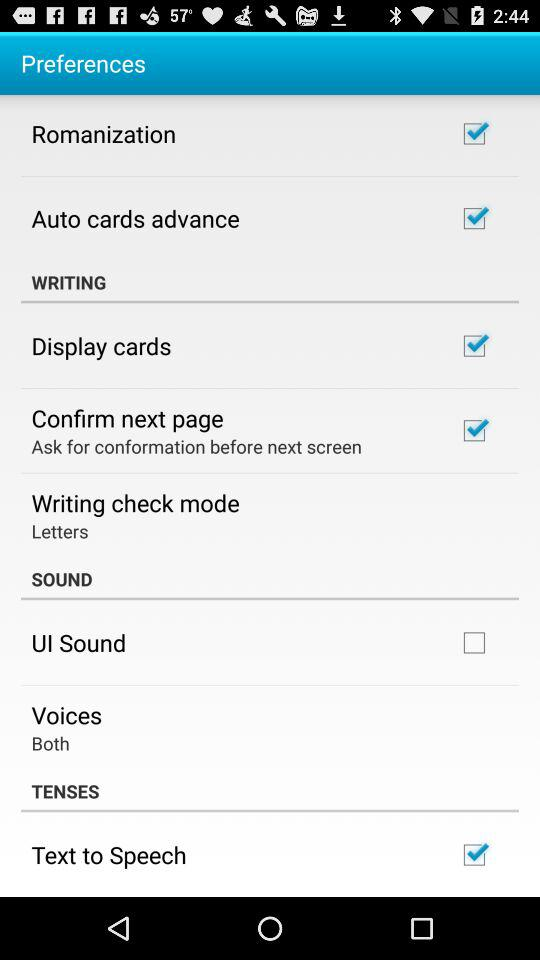How many check boxes are in the preferences screen?
Answer the question using a single word or phrase. 6 